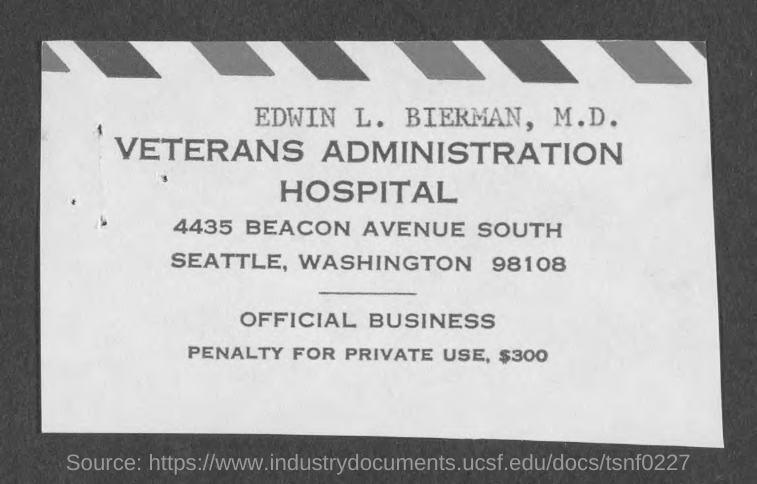Draw attention to some important aspects in this diagram. The Veterans Administration Hospital is located in the state of Washington. The penalty for private use is $300. According to the document, the name Edwin L. Bierman, M.D. was mentioned. 